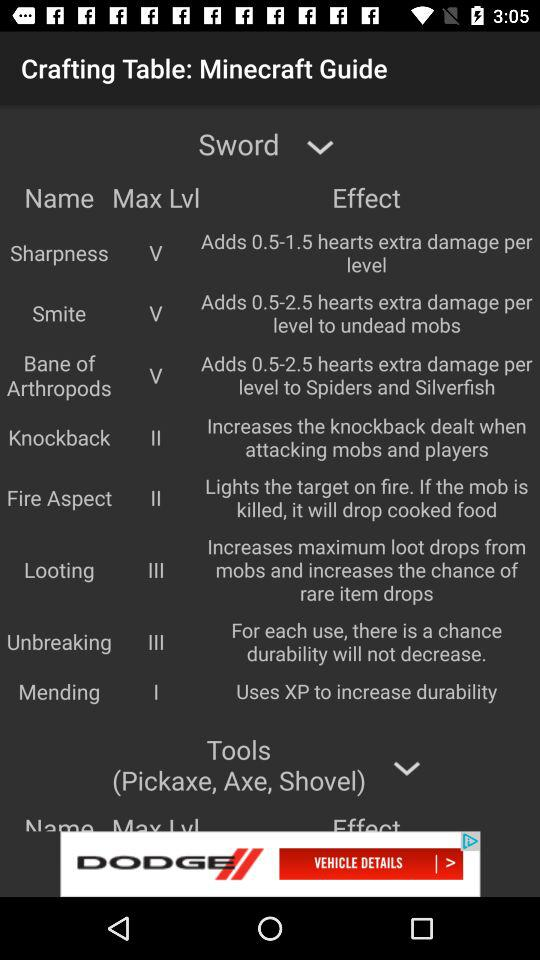What are the names of the tools? The names of the tools are: pickaxe, axe, and shovel. 